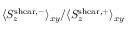Convert formula to latex. <formula><loc_0><loc_0><loc_500><loc_500>\langle S _ { z } ^ { s h e a r , - } \rangle _ { x y } / \langle S _ { z } ^ { s h e a r , + } \rangle _ { x y }</formula> 